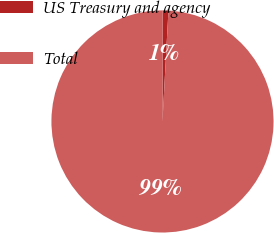Convert chart. <chart><loc_0><loc_0><loc_500><loc_500><pie_chart><fcel>US Treasury and agency<fcel>Total<nl><fcel>0.83%<fcel>99.17%<nl></chart> 